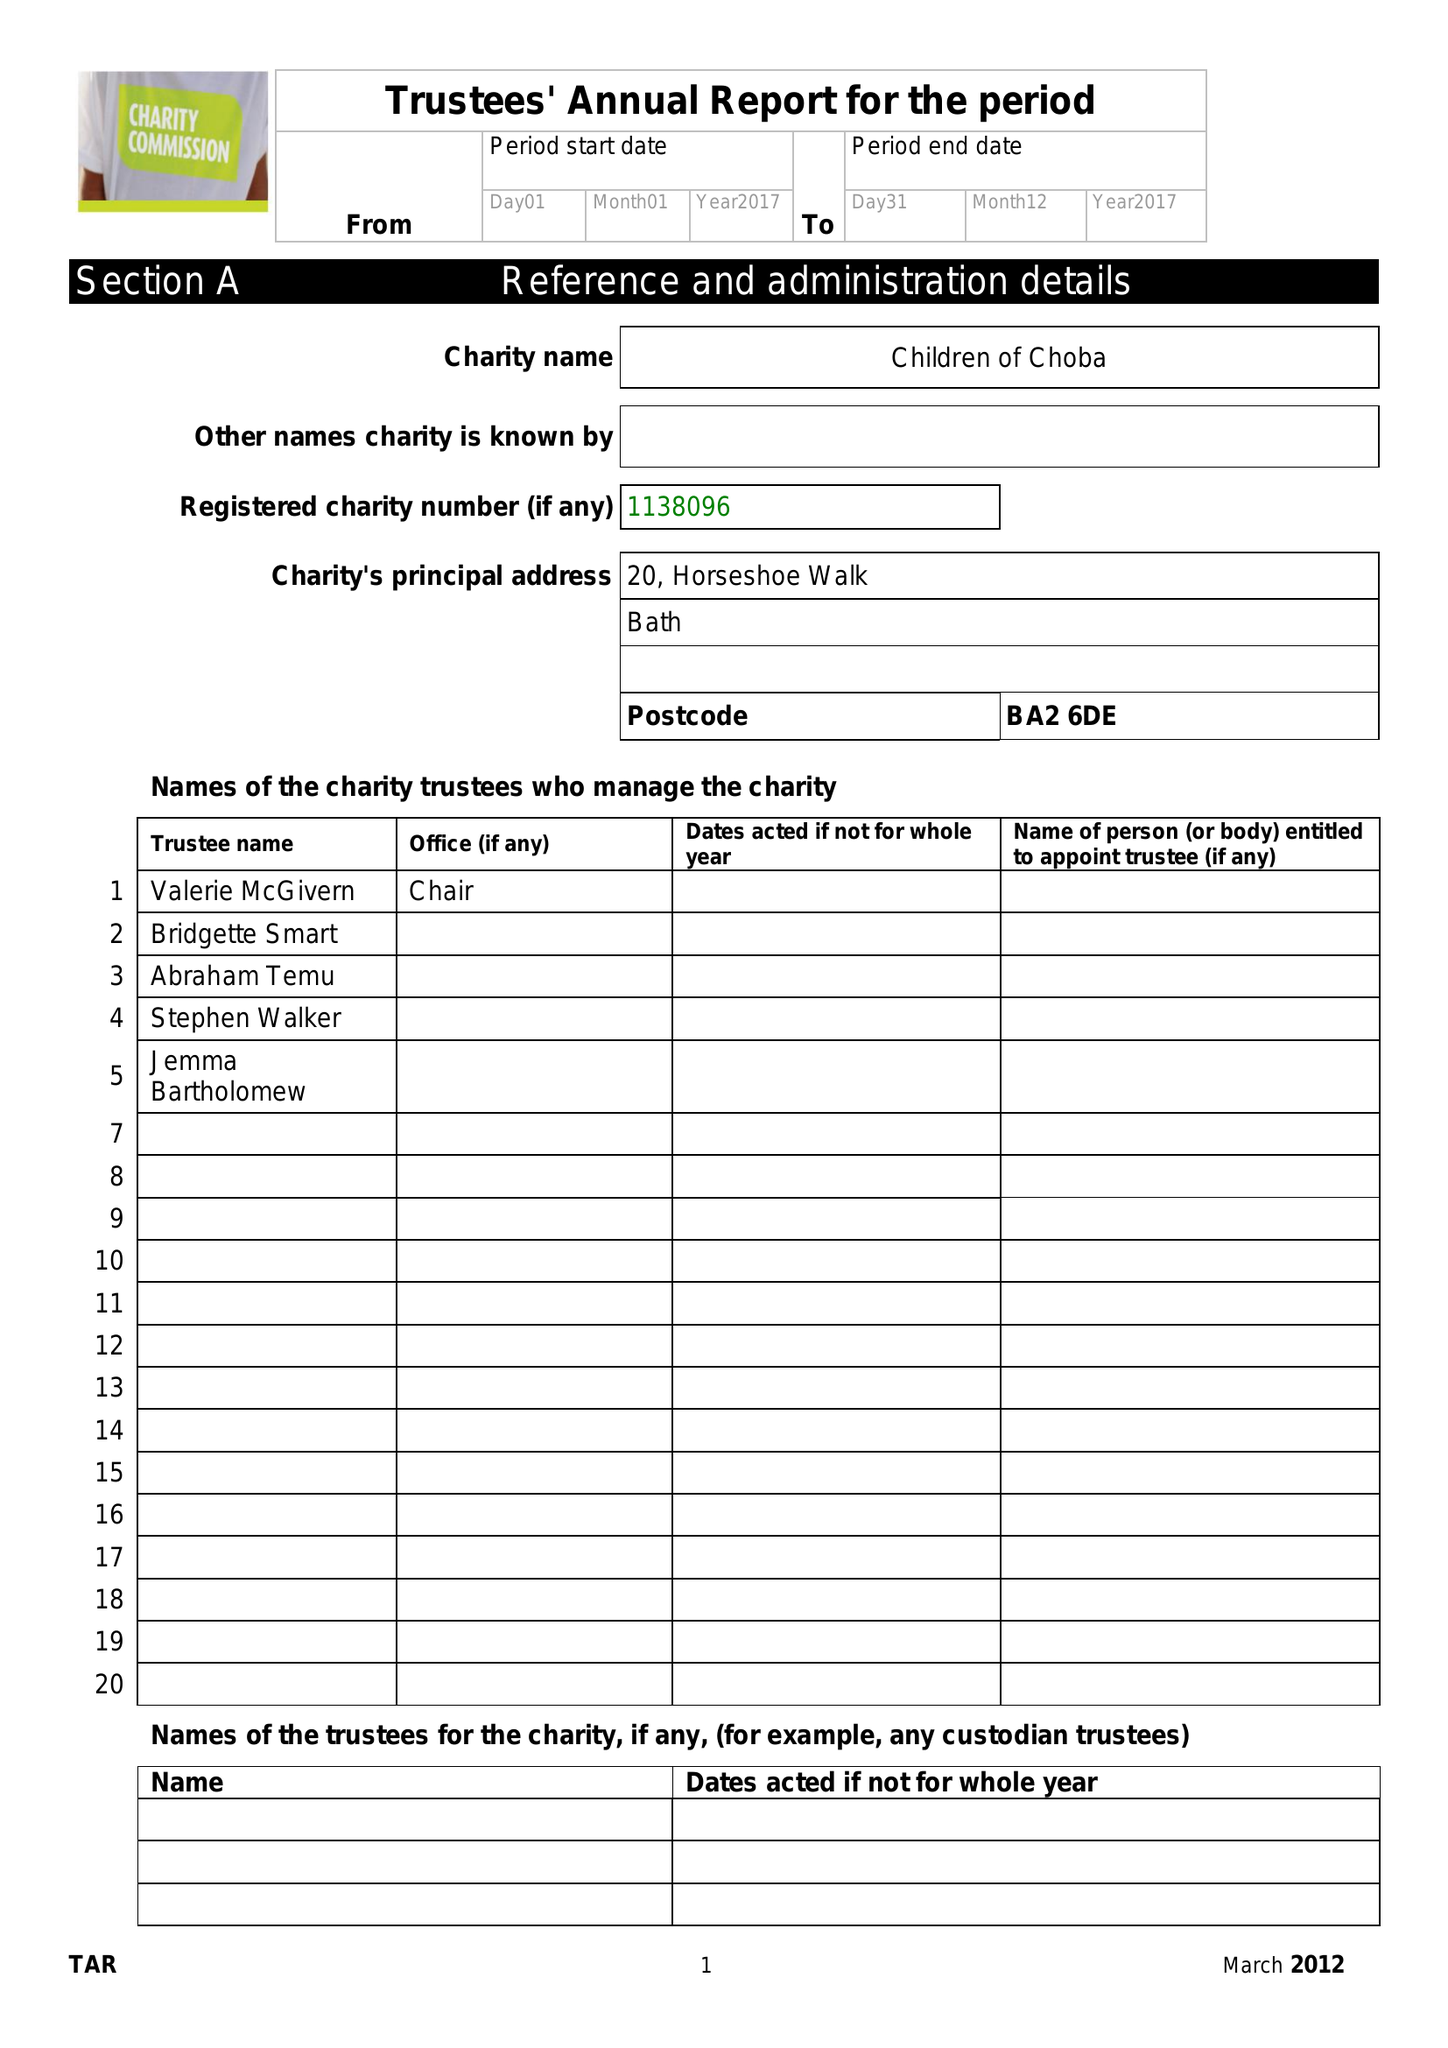What is the value for the income_annually_in_british_pounds?
Answer the question using a single word or phrase. 88541.00 